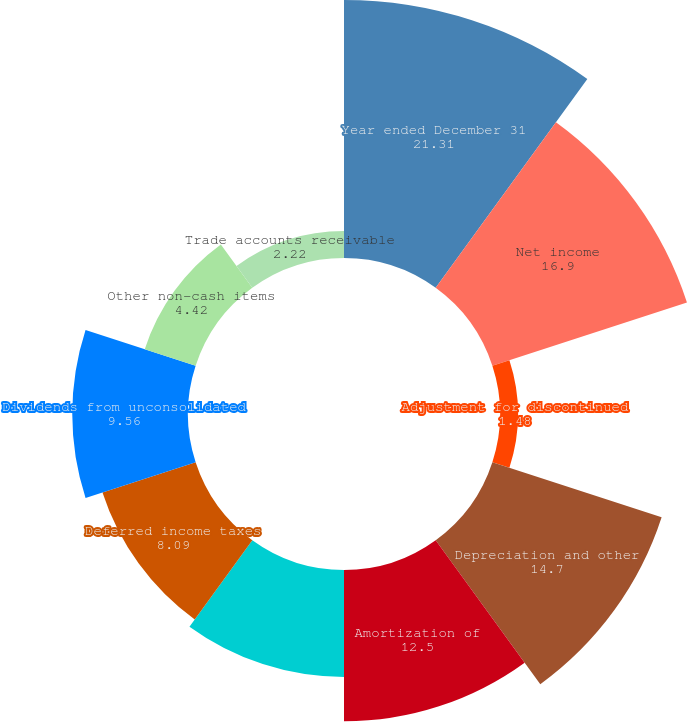Convert chart. <chart><loc_0><loc_0><loc_500><loc_500><pie_chart><fcel>Year ended December 31<fcel>Net income<fcel>Adjustment for discontinued<fcel>Depreciation and other<fcel>Amortization of<fcel>Share-based compensation<fcel>Deferred income taxes<fcel>Dividends from unconsolidated<fcel>Other non-cash items<fcel>Trade accounts receivable<nl><fcel>21.31%<fcel>16.9%<fcel>1.48%<fcel>14.7%<fcel>12.5%<fcel>8.83%<fcel>8.09%<fcel>9.56%<fcel>4.42%<fcel>2.22%<nl></chart> 